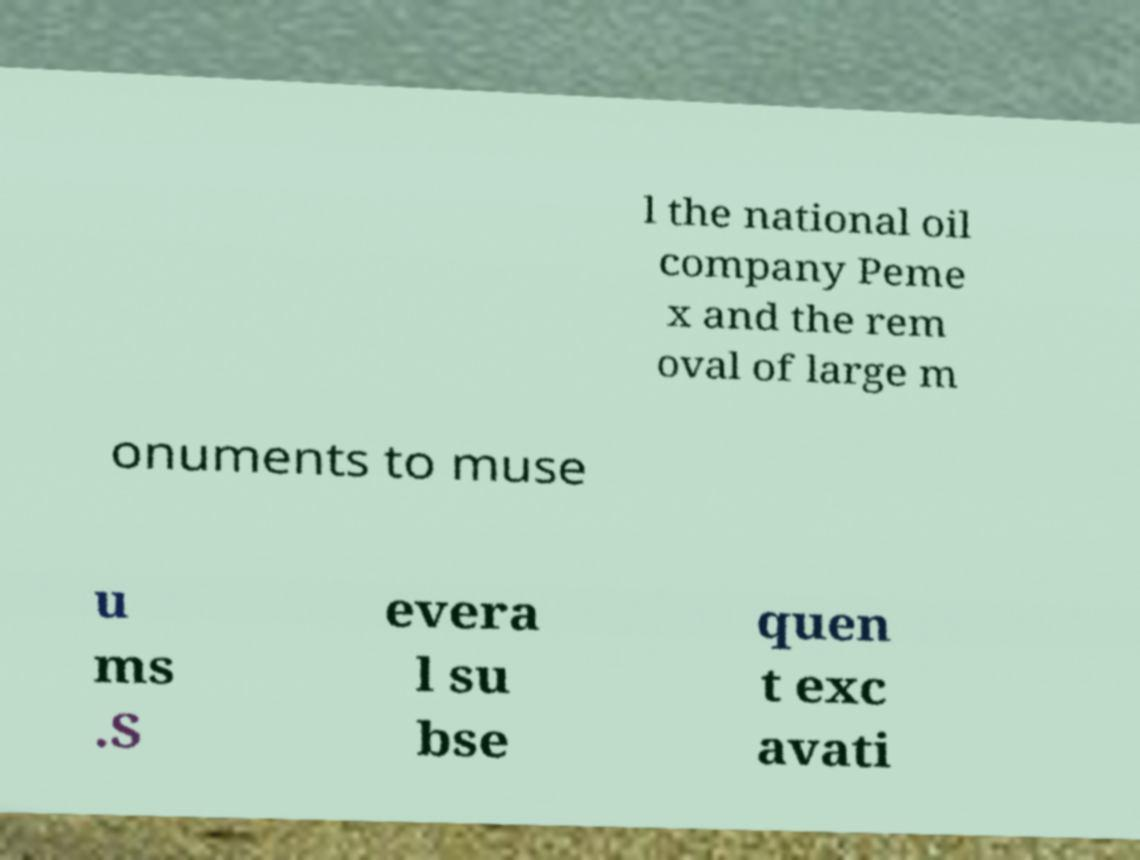There's text embedded in this image that I need extracted. Can you transcribe it verbatim? l the national oil company Peme x and the rem oval of large m onuments to muse u ms .S evera l su bse quen t exc avati 